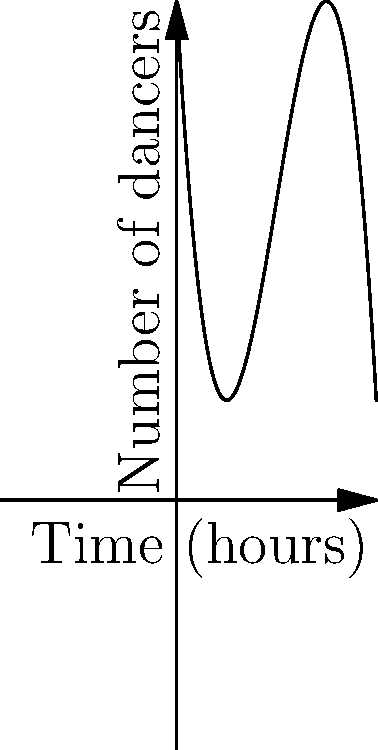As a security guard observing the dance floor, you notice that the number of dancers changes throughout the night. The occupancy of the dance floor can be modeled by the polynomial function $f(x) = -0.5x^3 + 6x^2 - 18x + 20$, where $x$ represents the number of hours since the club opened and $f(x)$ represents the number of dancers. At what time does the dance floor reach its peak occupancy? To find the peak occupancy, we need to determine the maximum point of the function. This occurs where the derivative of the function equals zero.

1. Find the derivative of $f(x)$:
   $f'(x) = -1.5x^2 + 12x - 18$

2. Set the derivative equal to zero and solve:
   $-1.5x^2 + 12x - 18 = 0$
   
3. This is a quadratic equation. We can solve it using the quadratic formula:
   $x = \frac{-b \pm \sqrt{b^2 - 4ac}}{2a}$
   
   Where $a = -1.5$, $b = 12$, and $c = -18$

4. Plugging in these values:
   $x = \frac{-12 \pm \sqrt{12^2 - 4(-1.5)(-18)}}{2(-1.5)}$
   
   $x = \frac{-12 \pm \sqrt{144 - 108}}{-3}$
   
   $x = \frac{-12 \pm \sqrt{36}}{-3}$
   
   $x = \frac{-12 \pm 6}{-3}$

5. This gives us two solutions:
   $x = \frac{-12 + 6}{-3} = 2$ or $x = \frac{-12 - 6}{-3} = 6$

6. The smaller value, $x = 2$, corresponds to the maximum point (peak) because the graph opens downward (negative coefficient for $x^3$).

Therefore, the dance floor reaches its peak occupancy 2 hours after the club opened.
Answer: 2 hours after opening 